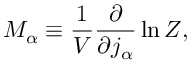Convert formula to latex. <formula><loc_0><loc_0><loc_500><loc_500>M _ { \alpha } \equiv \frac { 1 } { V } \frac { \partial } { \partial j _ { \alpha } } \ln Z ,</formula> 